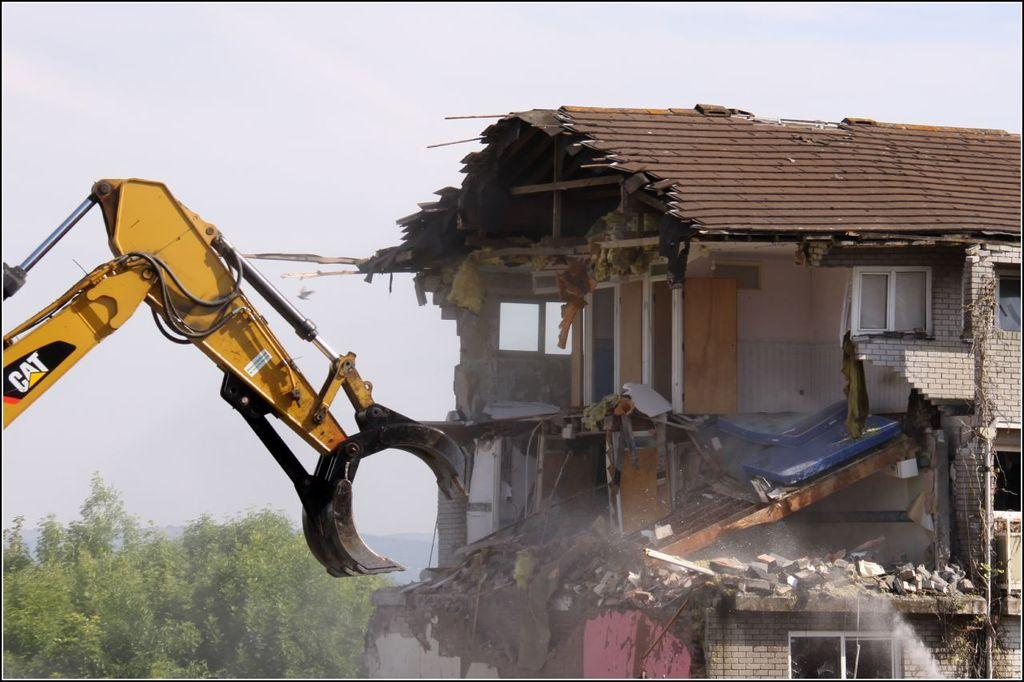What is the main object in the image? There is a crane in the image. What is located to the right of the crane? There is a building to the right of the crane. What is located to the left of the crane? There are trees to the left of the crane. What is visible at the top of the image? The sky is visible at the top of the image. What type of scissors can be seen cutting the form in the image? There are no scissors or forms present in the image; it features a crane, a building, trees, and the sky. 